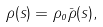<formula> <loc_0><loc_0><loc_500><loc_500>\rho ( s ) = \rho _ { o } \bar { \rho } ( s ) ,</formula> 